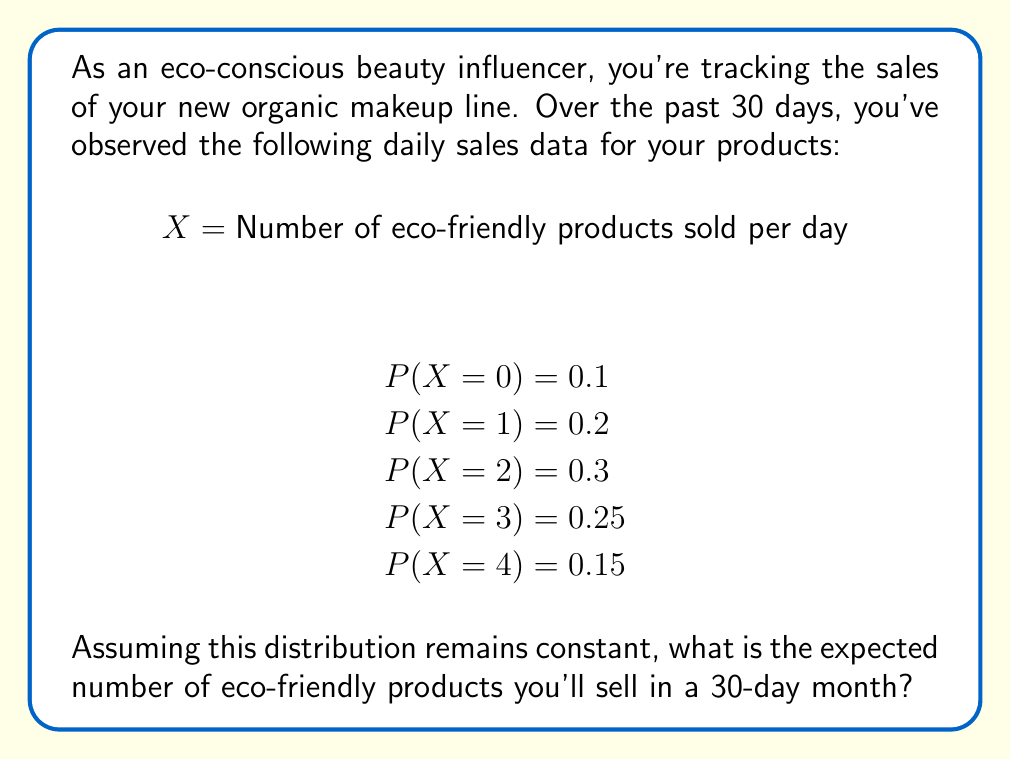Can you answer this question? To solve this problem, we need to follow these steps:

1. Calculate the expected value (E[X]) of the daily sales:
   
   $$E[X] = \sum_{x} x \cdot P(X = x)$$
   
   $$E[X] = 0 \cdot 0.1 + 1 \cdot 0.2 + 2 \cdot 0.3 + 3 \cdot 0.25 + 4 \cdot 0.15$$
   
   $$E[X] = 0 + 0.2 + 0.6 + 0.75 + 0.6 = 2.15$$

2. Since the question asks for the expected number of products sold in a 30-day month, we need to multiply the daily expected value by 30:

   $$E[X_{month}] = 30 \cdot E[X]$$
   
   $$E[X_{month}] = 30 \cdot 2.15 = 64.5$$

Therefore, the expected number of eco-friendly products sold in a 30-day month is 64.5.
Answer: 64.5 products 